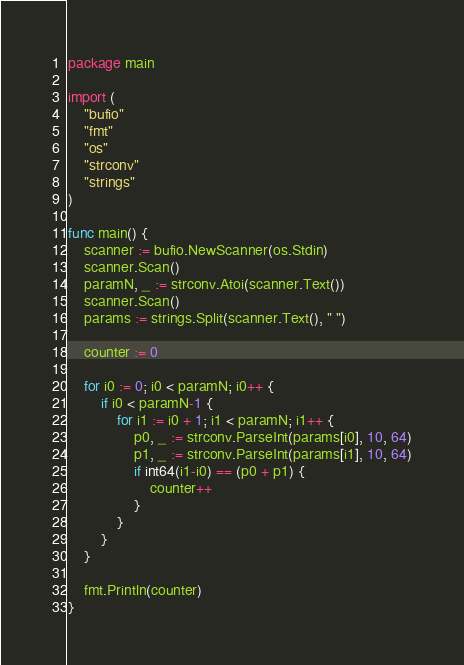Convert code to text. <code><loc_0><loc_0><loc_500><loc_500><_Go_>package main

import (
	"bufio"
	"fmt"
	"os"
	"strconv"
	"strings"
)

func main() {
	scanner := bufio.NewScanner(os.Stdin)
	scanner.Scan()
	paramN, _ := strconv.Atoi(scanner.Text())
	scanner.Scan()
	params := strings.Split(scanner.Text(), " ")

	counter := 0

	for i0 := 0; i0 < paramN; i0++ {
		if i0 < paramN-1 {
			for i1 := i0 + 1; i1 < paramN; i1++ {
				p0, _ := strconv.ParseInt(params[i0], 10, 64)
				p1, _ := strconv.ParseInt(params[i1], 10, 64)
				if int64(i1-i0) == (p0 + p1) {
					counter++
				}
			}
		}
	}

	fmt.Println(counter)
}
</code> 